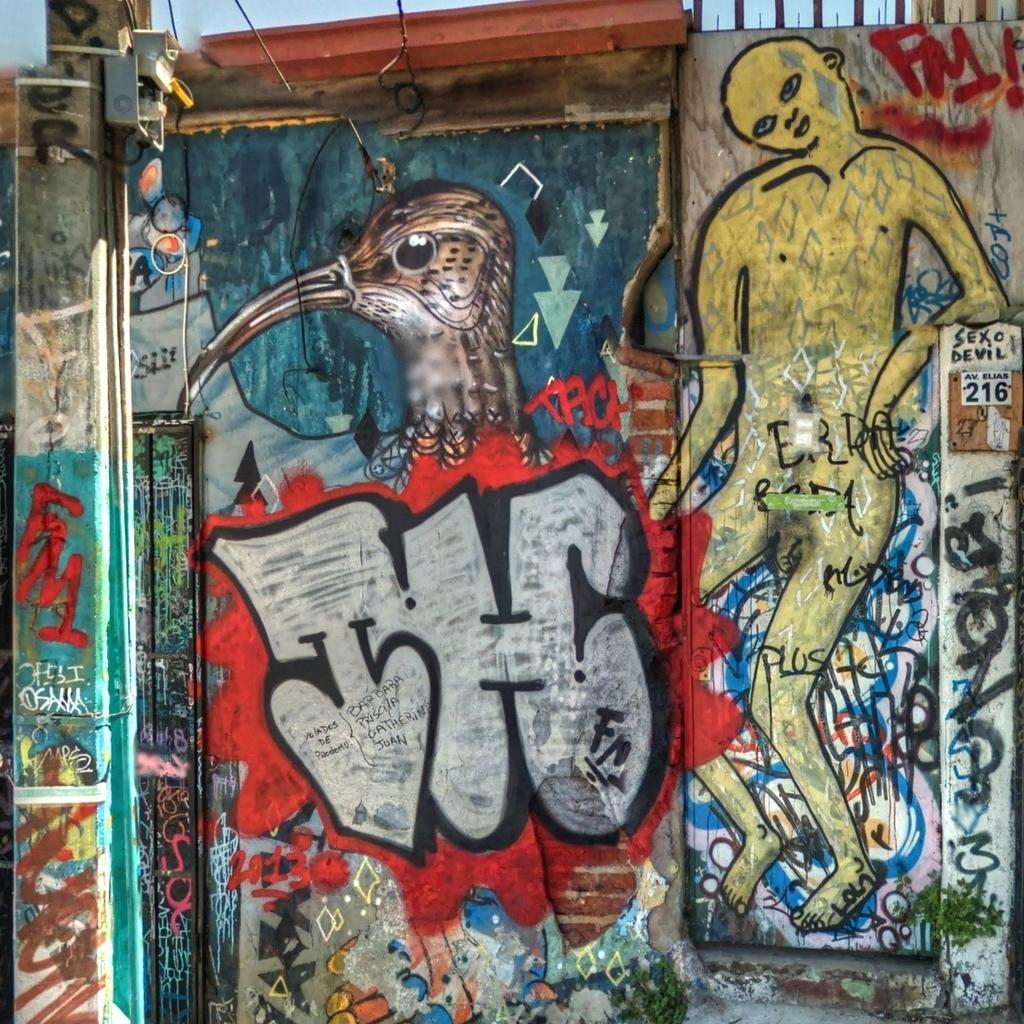What is present on the wall in the image? There is a painting on the wall in the image. What does the painting depict? The painting depicts a bird and a human. What can be seen in the background of the painting? There is a sky visible in the image. Where is the basin located in the image? There is no basin present in the image. What type of rhythm can be heard coming from the painting? The painting is a still image and does not produce any sound or rhythm. 